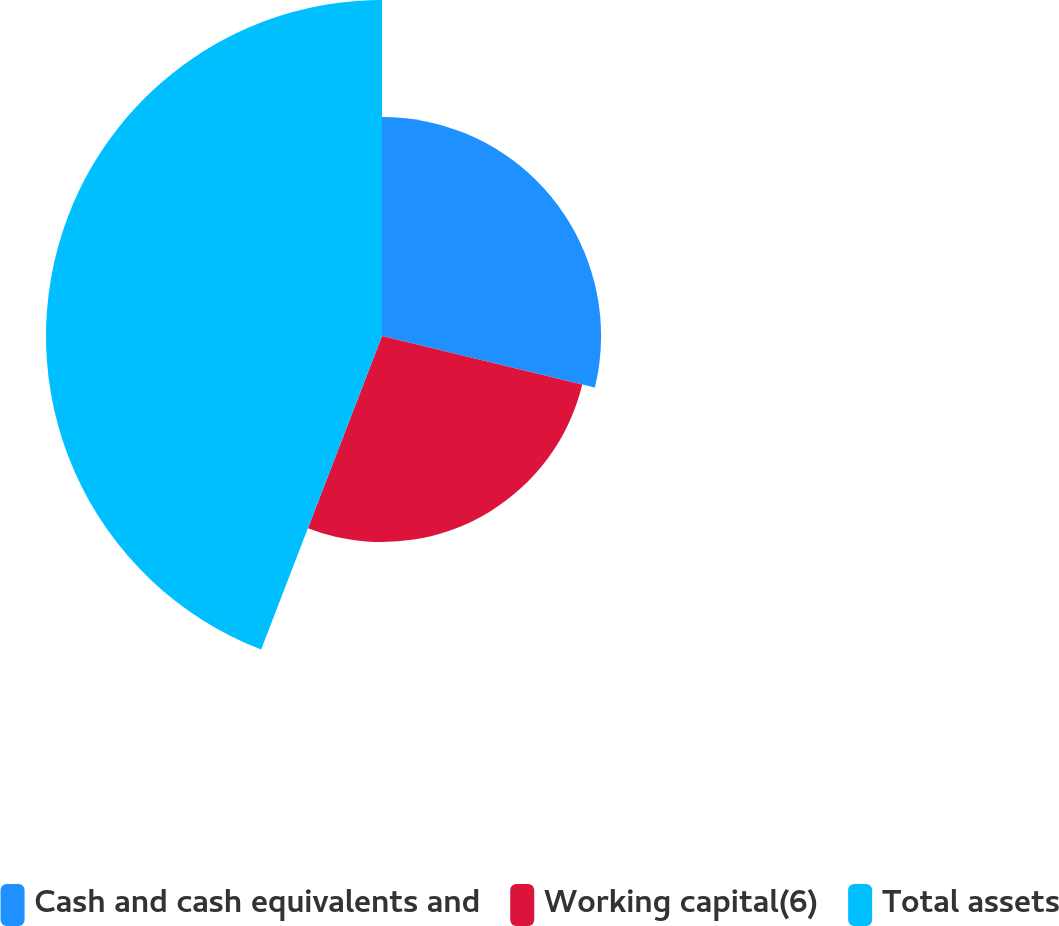<chart> <loc_0><loc_0><loc_500><loc_500><pie_chart><fcel>Cash and cash equivalents and<fcel>Working capital(6)<fcel>Total assets<nl><fcel>28.78%<fcel>27.07%<fcel>44.14%<nl></chart> 